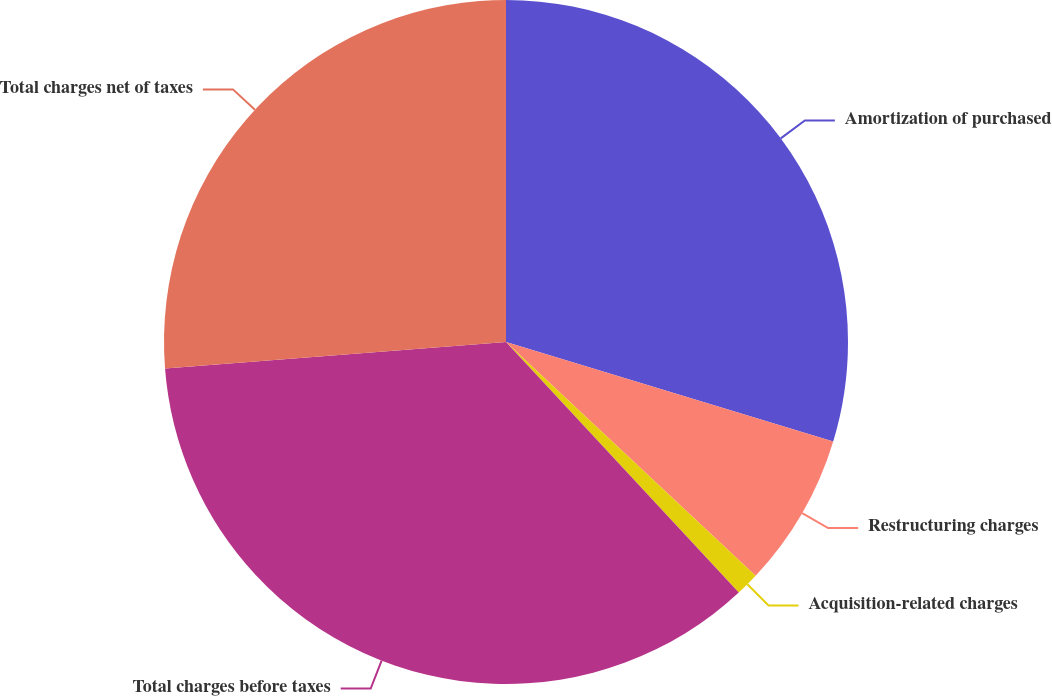Convert chart to OTSL. <chart><loc_0><loc_0><loc_500><loc_500><pie_chart><fcel>Amortization of purchased<fcel>Restructuring charges<fcel>Acquisition-related charges<fcel>Total charges before taxes<fcel>Total charges net of taxes<nl><fcel>29.7%<fcel>7.28%<fcel>1.11%<fcel>35.68%<fcel>26.24%<nl></chart> 